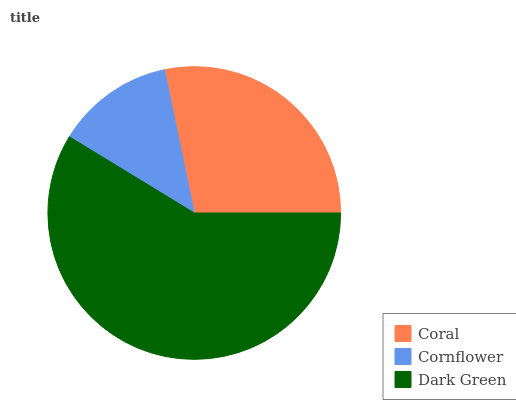Is Cornflower the minimum?
Answer yes or no. Yes. Is Dark Green the maximum?
Answer yes or no. Yes. Is Dark Green the minimum?
Answer yes or no. No. Is Cornflower the maximum?
Answer yes or no. No. Is Dark Green greater than Cornflower?
Answer yes or no. Yes. Is Cornflower less than Dark Green?
Answer yes or no. Yes. Is Cornflower greater than Dark Green?
Answer yes or no. No. Is Dark Green less than Cornflower?
Answer yes or no. No. Is Coral the high median?
Answer yes or no. Yes. Is Coral the low median?
Answer yes or no. Yes. Is Dark Green the high median?
Answer yes or no. No. Is Dark Green the low median?
Answer yes or no. No. 